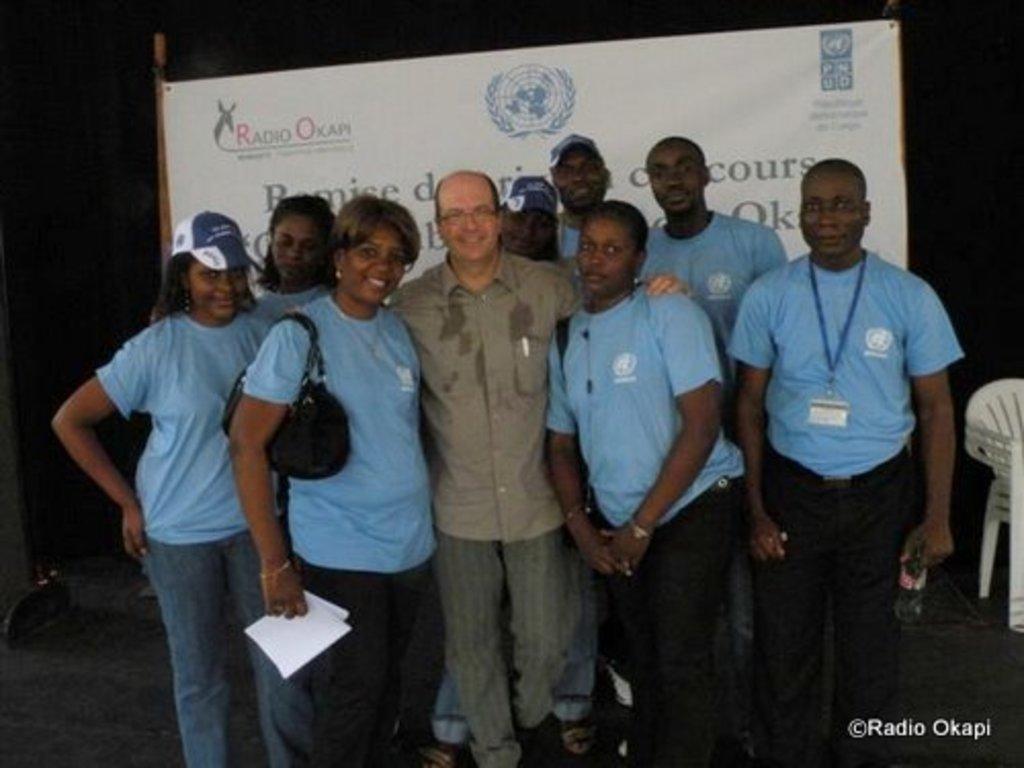In one or two sentences, can you explain what this image depicts? In this image we can see a few people standing, there are a few chairs, in the background there is a written text on the board. 